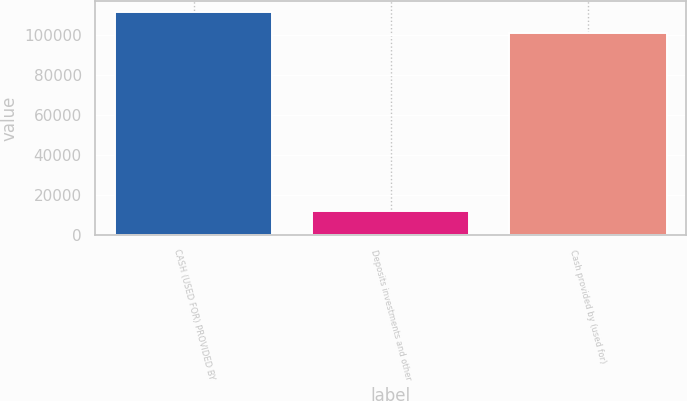Convert chart. <chart><loc_0><loc_0><loc_500><loc_500><bar_chart><fcel>CASH (USED FOR) PROVIDED BY<fcel>Deposits investments and other<fcel>Cash provided by (used for)<nl><fcel>111743<fcel>12248<fcel>101442<nl></chart> 